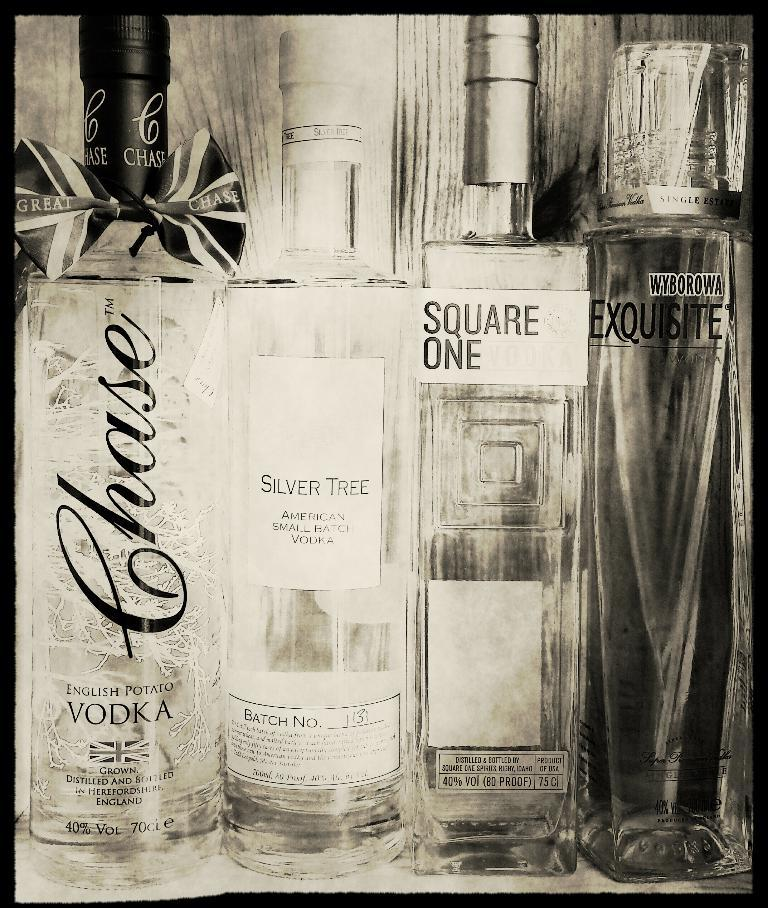Provide a one-sentence caption for the provided image. A bottle of liquor that describes itself as English Potato Vodka. 